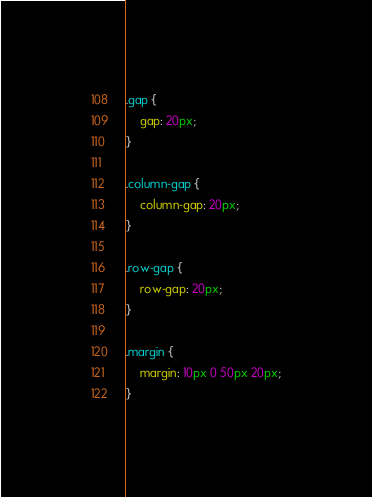<code> <loc_0><loc_0><loc_500><loc_500><_CSS_>.gap {
    gap: 20px;
}

.column-gap {
    column-gap: 20px;
}

.row-gap {
    row-gap: 20px;
}

.margin {
    margin: 10px 0 50px 20px;
}</code> 